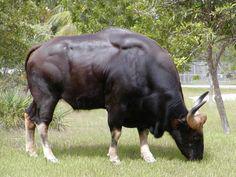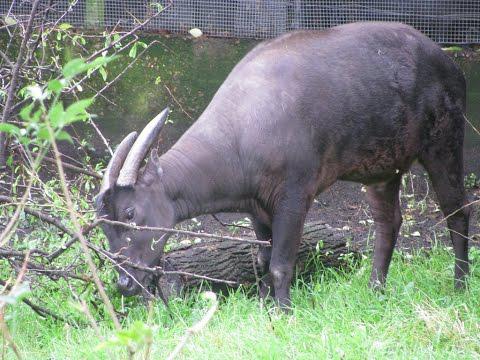The first image is the image on the left, the second image is the image on the right. Examine the images to the left and right. Is the description "Each image contains exactly one horned animal, and the horned animal in the right image has its face turned to the camera." accurate? Answer yes or no. No. 